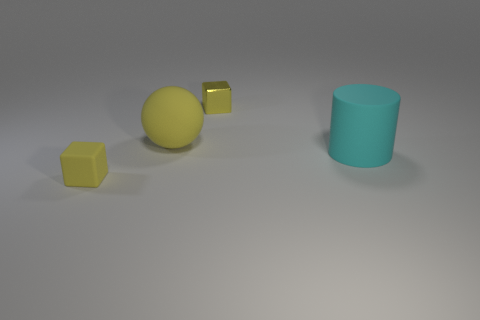What material is the cylinder?
Make the answer very short. Rubber. Is the tiny rubber object the same color as the big rubber sphere?
Make the answer very short. Yes. Are there fewer yellow matte things that are left of the big yellow sphere than tiny metal blocks?
Keep it short and to the point. No. There is a block that is right of the small yellow matte cube; what is its color?
Provide a succinct answer. Yellow. The big yellow thing has what shape?
Offer a very short reply. Sphere. There is a rubber object on the right side of the tiny yellow shiny object behind the tiny matte thing; is there a big cylinder on the right side of it?
Your response must be concise. No. There is a block that is in front of the cube that is to the right of the cube that is left of the metal cube; what is its color?
Give a very brief answer. Yellow. There is another yellow thing that is the same shape as the shiny thing; what material is it?
Provide a succinct answer. Rubber. There is a yellow cube that is behind the thing to the right of the yellow shiny block; what is its size?
Ensure brevity in your answer.  Small. What is the material of the small yellow block that is in front of the large yellow matte sphere?
Your answer should be compact. Rubber. 